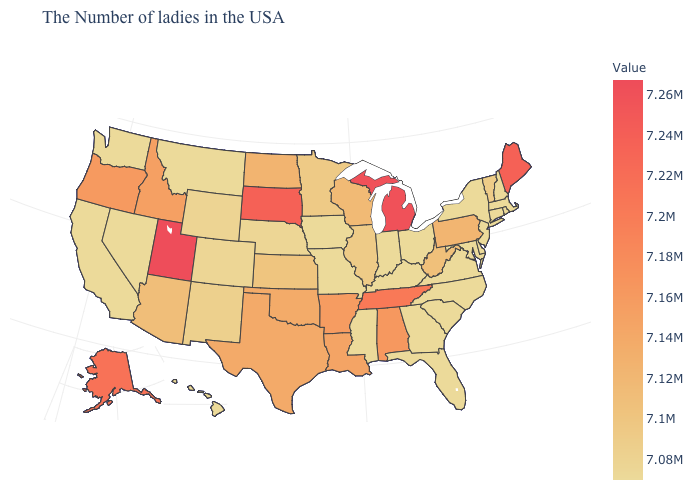Is the legend a continuous bar?
Concise answer only. Yes. Does the map have missing data?
Be succinct. No. Is the legend a continuous bar?
Keep it brief. Yes. Does North Dakota have the lowest value in the USA?
Concise answer only. No. 